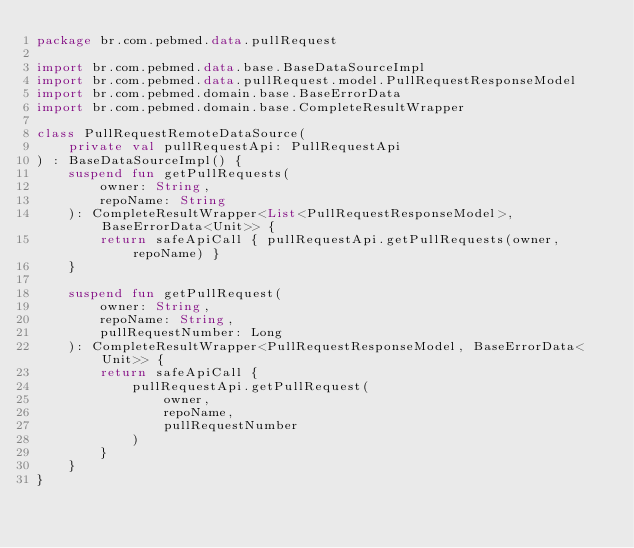Convert code to text. <code><loc_0><loc_0><loc_500><loc_500><_Kotlin_>package br.com.pebmed.data.pullRequest

import br.com.pebmed.data.base.BaseDataSourceImpl
import br.com.pebmed.data.pullRequest.model.PullRequestResponseModel
import br.com.pebmed.domain.base.BaseErrorData
import br.com.pebmed.domain.base.CompleteResultWrapper

class PullRequestRemoteDataSource(
    private val pullRequestApi: PullRequestApi
) : BaseDataSourceImpl() {
    suspend fun getPullRequests(
        owner: String,
        repoName: String
    ): CompleteResultWrapper<List<PullRequestResponseModel>, BaseErrorData<Unit>> {
        return safeApiCall { pullRequestApi.getPullRequests(owner, repoName) }
    }

    suspend fun getPullRequest(
        owner: String,
        repoName: String,
        pullRequestNumber: Long
    ): CompleteResultWrapper<PullRequestResponseModel, BaseErrorData<Unit>> {
        return safeApiCall {
            pullRequestApi.getPullRequest(
                owner,
                repoName,
                pullRequestNumber
            )
        }
    }
}</code> 